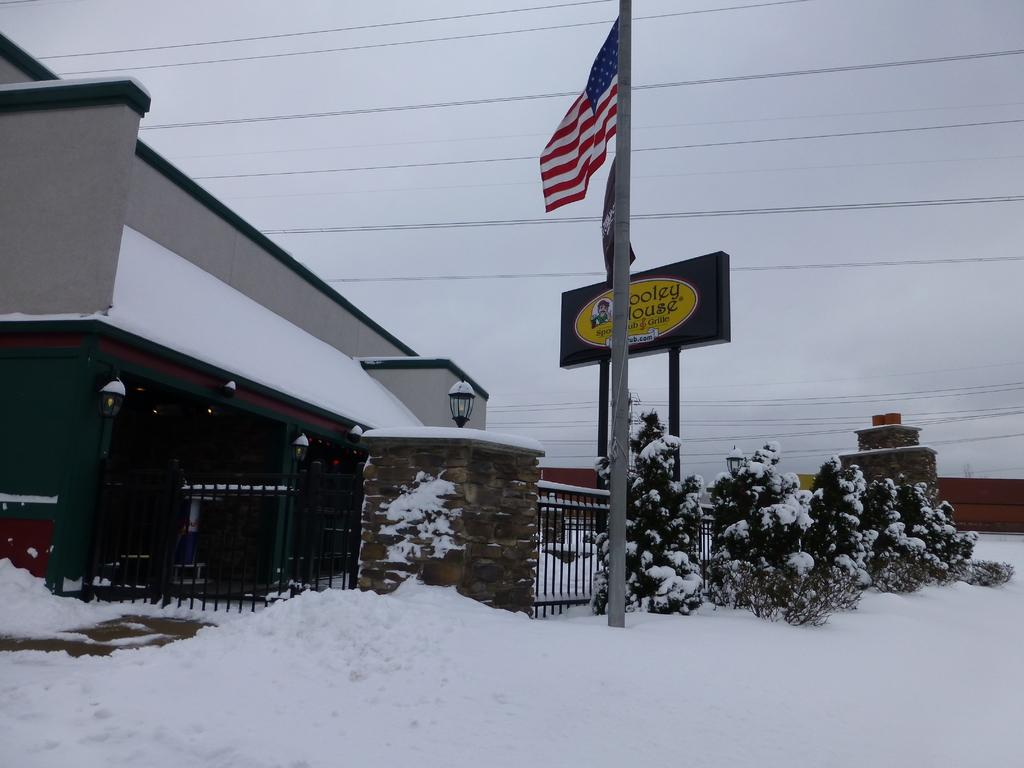What can be seen flying or waving in the image? There is a flag in the image. How many unspecified objects are present in the image? There are three unspecified objects in the image. What is a flat, raised surface that can be seen in the image? There is a board in the image. What type of barrier can be seen in the image? There is a fence in the image. What type of structures are visible in the image? There are buildings in the image. What can be seen in the background of the image? There are wires, a light, snow, and the sky visible in the background of the image. Where is the dock located in the image? There is no dock present in the image. What type of vehicle is the aunt driving in the image? There is no aunt or vehicle present in the image. 